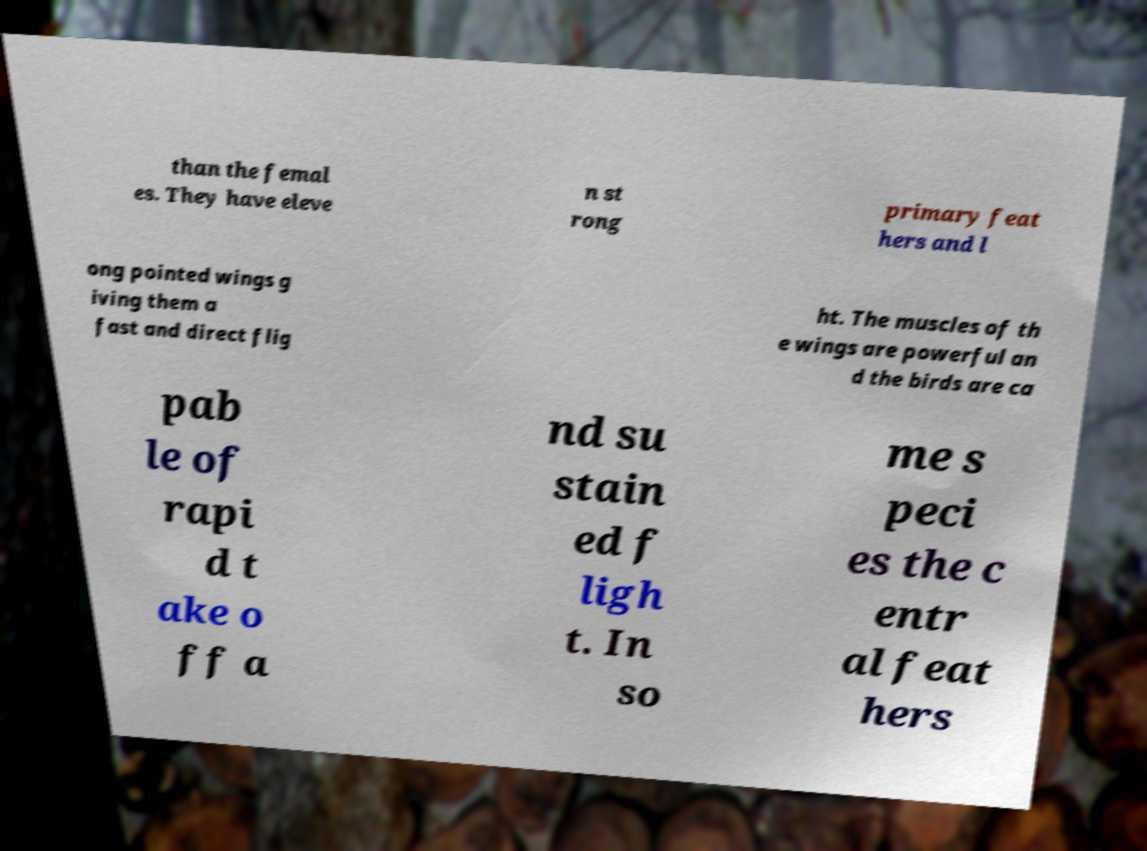Can you read and provide the text displayed in the image?This photo seems to have some interesting text. Can you extract and type it out for me? than the femal es. They have eleve n st rong primary feat hers and l ong pointed wings g iving them a fast and direct flig ht. The muscles of th e wings are powerful an d the birds are ca pab le of rapi d t ake o ff a nd su stain ed f ligh t. In so me s peci es the c entr al feat hers 